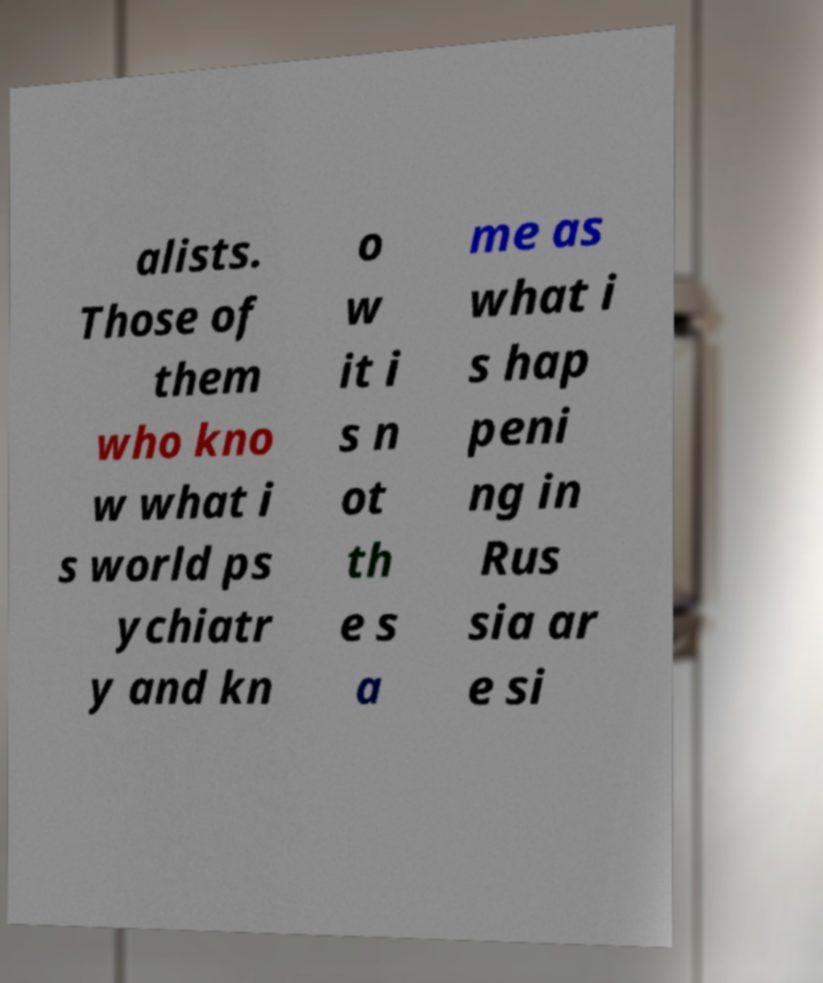Please read and relay the text visible in this image. What does it say? alists. Those of them who kno w what i s world ps ychiatr y and kn o w it i s n ot th e s a me as what i s hap peni ng in Rus sia ar e si 